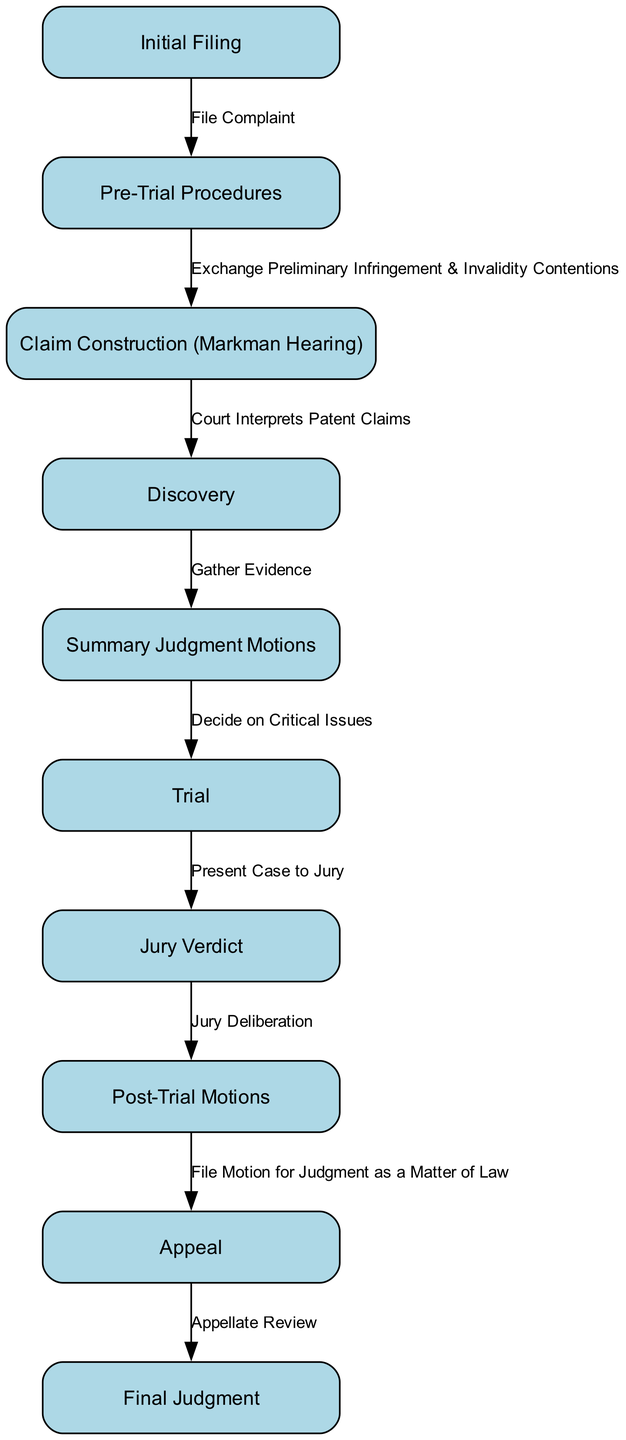What is the first step in the litigation process? The diagram indicates that the first step is "Initial Filing." This node is the starting point, with an edge leading from it to the next step labeled "Pre-Trial Procedures," indicating it is the foundation of the process.
Answer: Initial Filing How many nodes are in the diagram? To find the total number of nodes, we can count each labeled step in the diagram. There are ten unique steps represented as nodes in the process of patent infringement litigation.
Answer: 10 What follows after the Claim Construction step? According to the diagram, "Discovery" follows "Claim Construction." There is an edge connecting these two nodes, indicating that Discovery happens directly after Claim Construction.
Answer: Discovery What is the last step in the process? The final step in the sequence is labeled "Final Judgment." It is the endpoint of the litigation process, as illustrated by the edge leading from the previous step, "Appeal," to it.
Answer: Final Judgment What do the Pre-Trial Procedures involve? The Pre-Trial Procedures involve the exchange of preliminary infringement and invalidity contentions. This is captured by the edge connecting the "Pre-Trial Procedures" node to the "Claim Construction" node, explaining the nature of activities during this phase.
Answer: Exchange Preliminary Infringement & Invalidity Contentions Which step involves jury deliberation? The step involving jury deliberation is denoted as "Jury Verdict." This directly follows the "Trial" step, and a clear edge shows the flow from Trial to Jury Verdict, indicating that the jury's discussion occurs here.
Answer: Jury Verdict What is required before moving to the appeal stage? To move to the "Appeal" stage, one must first complete the "Post-Trial Motions" step. The edge from Post-Trial Motions to Appeal indicates that this step is essential before potentially seeking an appeal.
Answer: Post-Trial Motions How does the Summary Judgment step relate to the Trial step? "Summary Judgment Motions" precede "Trial," as indicated by the connecting edge. The arrow from Summary Judgment to Trial implies that the issues decided in the Summary Judgment step must be resolved before a Trial can occur.
Answer: Decide on Critical Issues How many edges are connecting the nodes in the diagram? To determine the total number of edges, we can count all the connections represented in the diagram. There are nine edges that link the nodes together, showcasing the flow between steps in the litigation process.
Answer: 9 